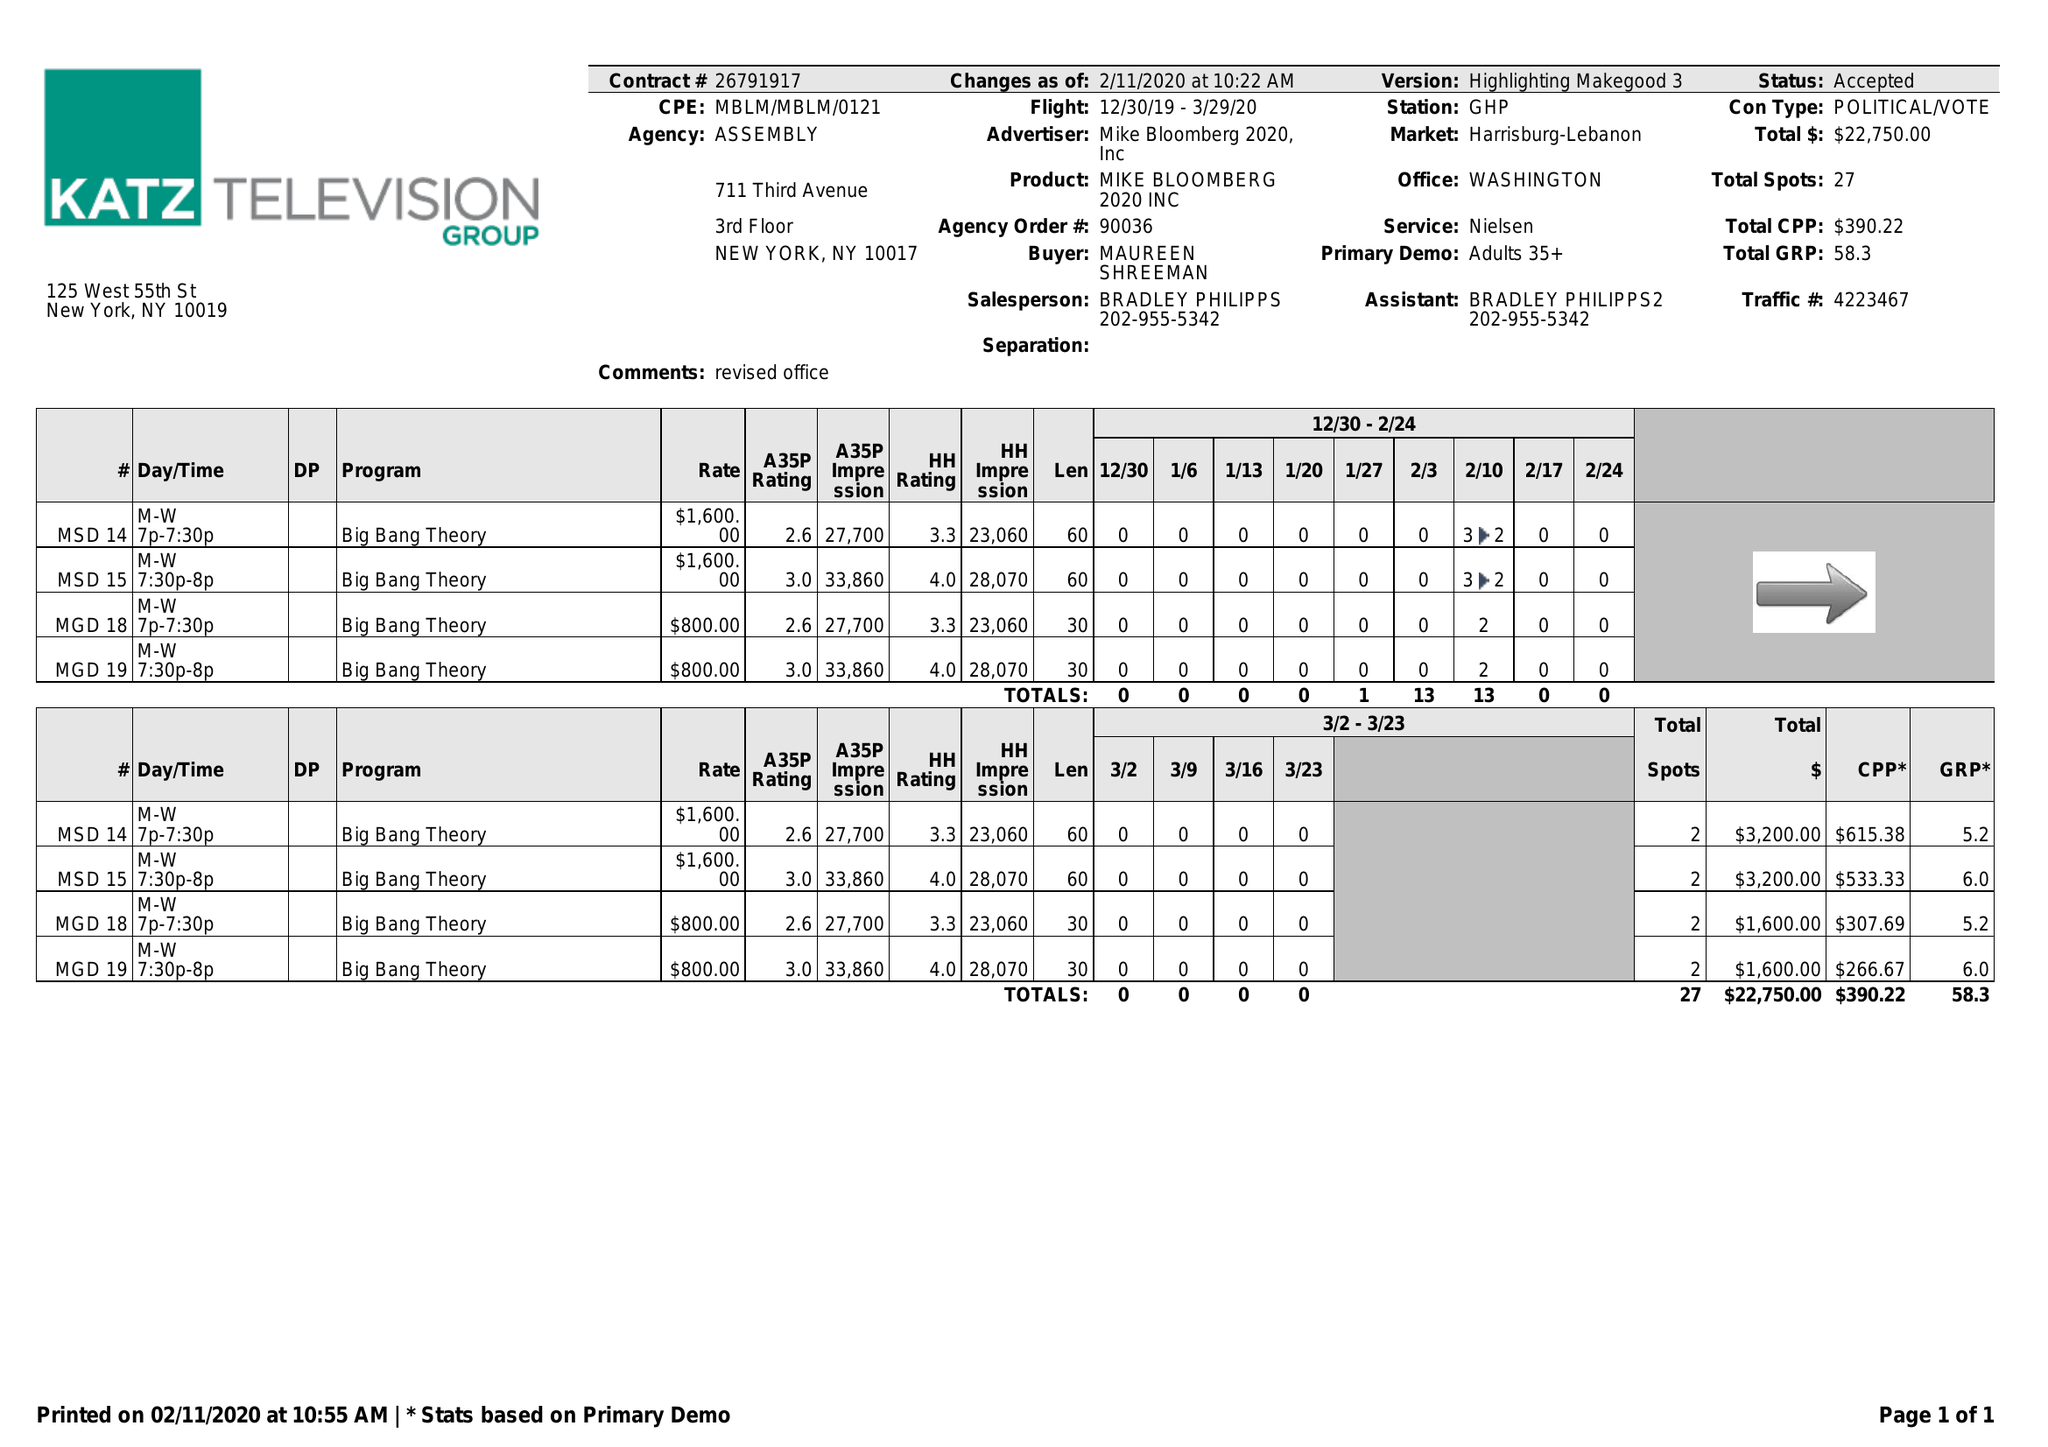What is the value for the advertiser?
Answer the question using a single word or phrase. MIKE BLOOMBERG 2020, INC 